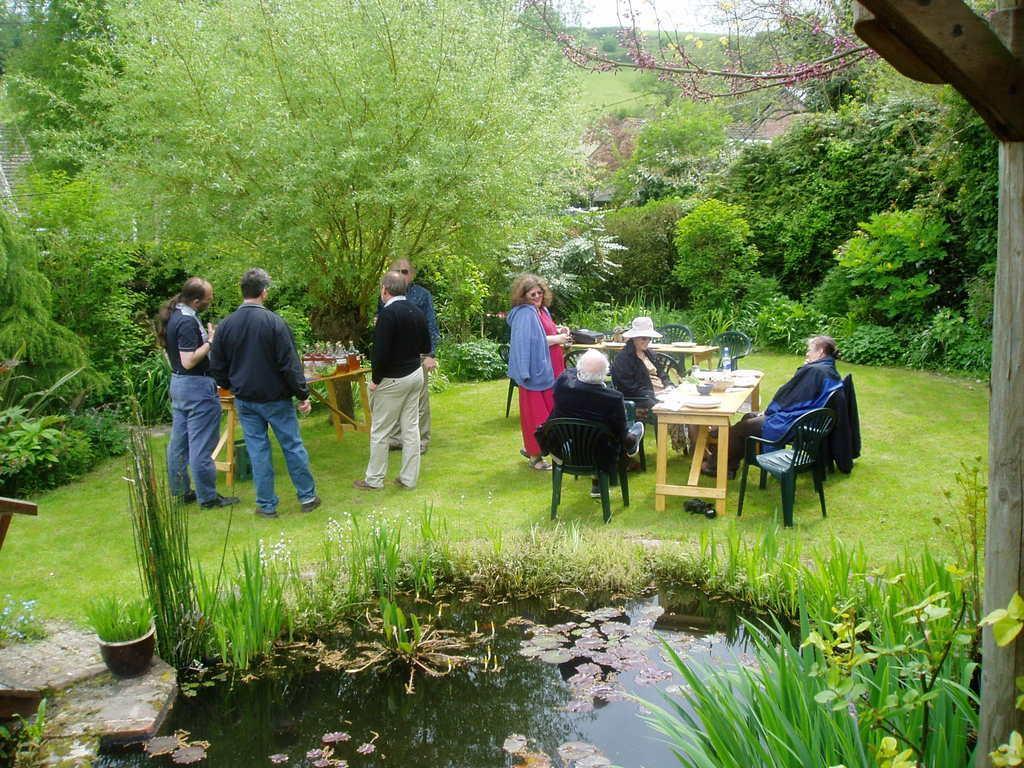In one or two sentences, can you explain what this image depicts? In this picture there are group of people standing. There are few bottles on the table. There is a woman standing. There are few people sitting. There is a water, grass. There are some trees at the background. 